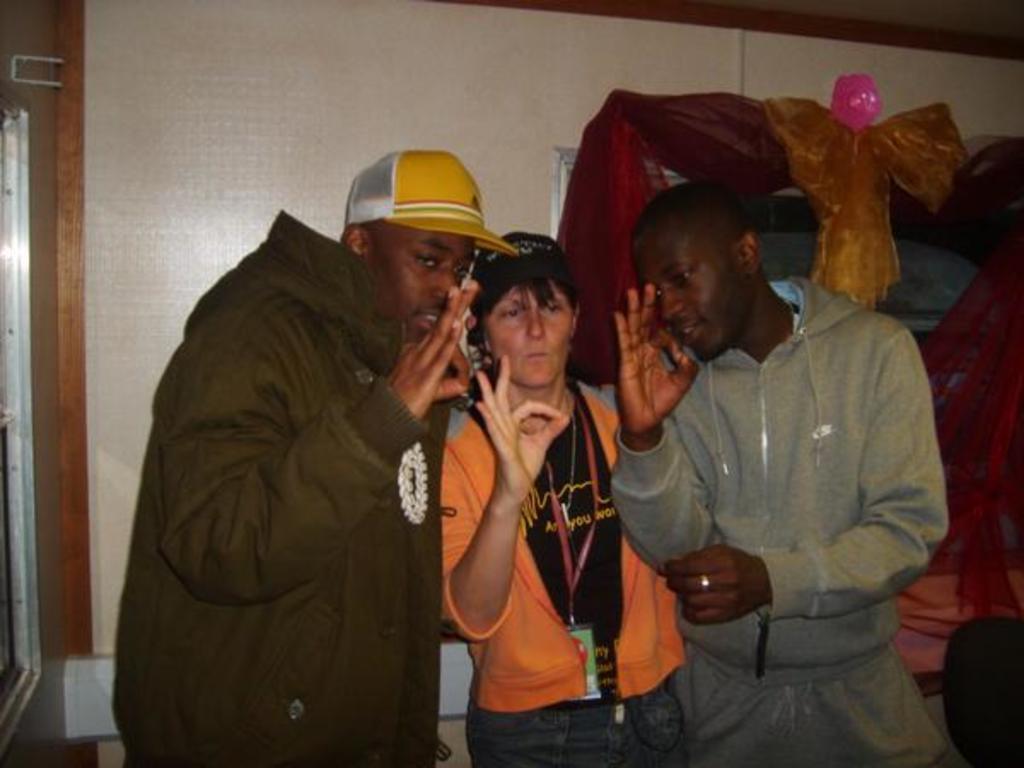In one or two sentences, can you explain what this image depicts? In the picture I can see three persons standing and showing super sign and there are few clothes and some other objects in the right corner. 